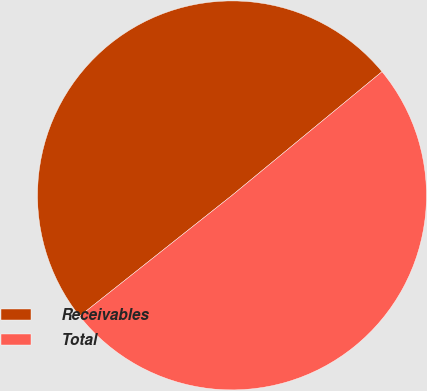Convert chart to OTSL. <chart><loc_0><loc_0><loc_500><loc_500><pie_chart><fcel>Receivables<fcel>Total<nl><fcel>49.69%<fcel>50.31%<nl></chart> 